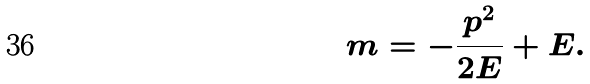<formula> <loc_0><loc_0><loc_500><loc_500>m = - \frac { p ^ { 2 } } { 2 E } + E .</formula> 